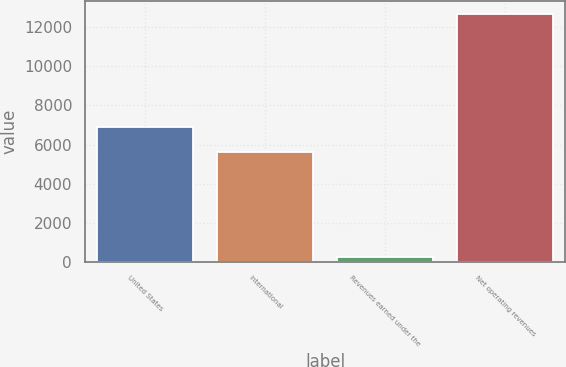<chart> <loc_0><loc_0><loc_500><loc_500><bar_chart><fcel>United States<fcel>International<fcel>Revenues earned under the<fcel>Net operating revenues<nl><fcel>6876.6<fcel>5629<fcel>226<fcel>12702<nl></chart> 